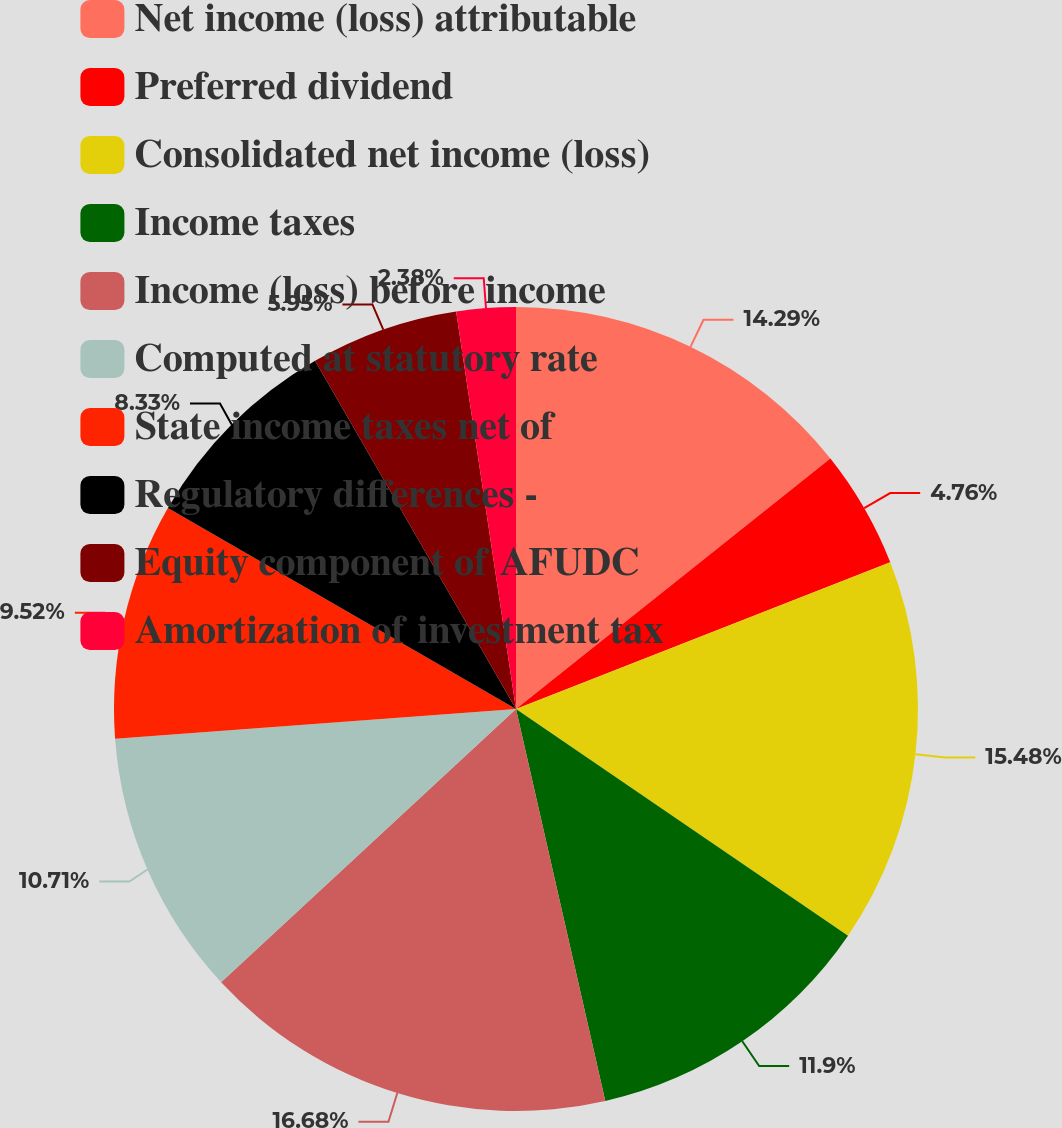<chart> <loc_0><loc_0><loc_500><loc_500><pie_chart><fcel>Net income (loss) attributable<fcel>Preferred dividend<fcel>Consolidated net income (loss)<fcel>Income taxes<fcel>Income (loss) before income<fcel>Computed at statutory rate<fcel>State income taxes net of<fcel>Regulatory differences -<fcel>Equity component of AFUDC<fcel>Amortization of investment tax<nl><fcel>14.29%<fcel>4.76%<fcel>15.48%<fcel>11.9%<fcel>16.67%<fcel>10.71%<fcel>9.52%<fcel>8.33%<fcel>5.95%<fcel>2.38%<nl></chart> 